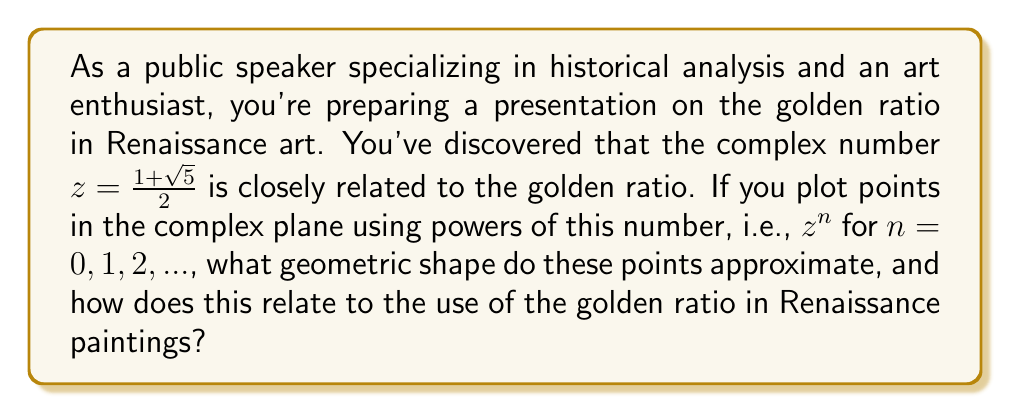Could you help me with this problem? Let's approach this step-by-step:

1) First, let's recall that the golden ratio, often denoted by $\phi$, is equal to $\frac{1 + \sqrt{5}}{2} \approx 1.618033988749895$.

2) The complex number $z = \frac{1 + \sqrt{5}}{2}$ is actually the golden ratio itself, but considered as a complex number on the real axis.

3) To plot the powers of $z$, we need to calculate $z^n$ for various values of $n$:

   $z^0 = 1$
   $z^1 = \frac{1 + \sqrt{5}}{2} \approx 1.618033988749895$
   $z^2 = \frac{3 + \sqrt{5}}{2} \approx 2.618033988749895$
   $z^3 = \frac{5 + 3\sqrt{5}}{2} \approx 4.236067977499790$
   ...

4) If we plot these points in the complex plane, we'll notice they all fall on the real axis and form a geometric sequence.

5) The ratio between consecutive terms in this sequence is constant and equal to $\phi$:

   $\frac{z^{n+1}}{z^n} = \frac{z^n \cdot z}{z^n} = z = \phi$

6) Now, let's consider the complex number $w = e^{i\theta}$, where $\theta = \frac{2\pi}{\phi} \approx 2.399963229728653$ radians or about 137.5°.

7) If we multiply our previous sequence by powers of $w$, we get:

   $z^0 \cdot w^0 = 1$
   $z^1 \cdot w^1 = \phi \cdot e^{i\theta}$
   $z^2 \cdot w^2 = \phi^2 \cdot e^{2i\theta}$
   $z^3 \cdot w^3 = \phi^3 \cdot e^{3i\theta}$
   ...

8) Plotting these points in the complex plane creates a spiral pattern. The magnitude of each point increases by a factor of $\phi$ each step, while the angle increases by $\theta \approx 137.5°$.

9) This spiral is known as the golden spiral, and it closely approximates the logarithmic spiral often found in nature.

10) In Renaissance art, the golden ratio was often used to create pleasing compositions. Artists would divide their canvases using the golden ratio, creating focal points and guiding the viewer's eye along paths reminiscent of the golden spiral.

11) For example, in Leonardo da Vinci's "Mona Lisa," the proportions of the face and body are said to conform to golden ratio principles. The spiral pattern we've discovered mathematically can often be overlaid on such paintings to reveal the underlying structure of the composition.
Answer: The points plotted using powers of the complex number $z = \frac{1 + \sqrt{5}}{2}$, when multiplied by $w^n$ where $w = e^{i\frac{2\pi}{\phi}}$, approximate a golden spiral. This logarithmic spiral is closely related to the use of the golden ratio in Renaissance paintings, where artists used it to create balanced, aesthetically pleasing compositions and guide the viewer's eye through the artwork. 